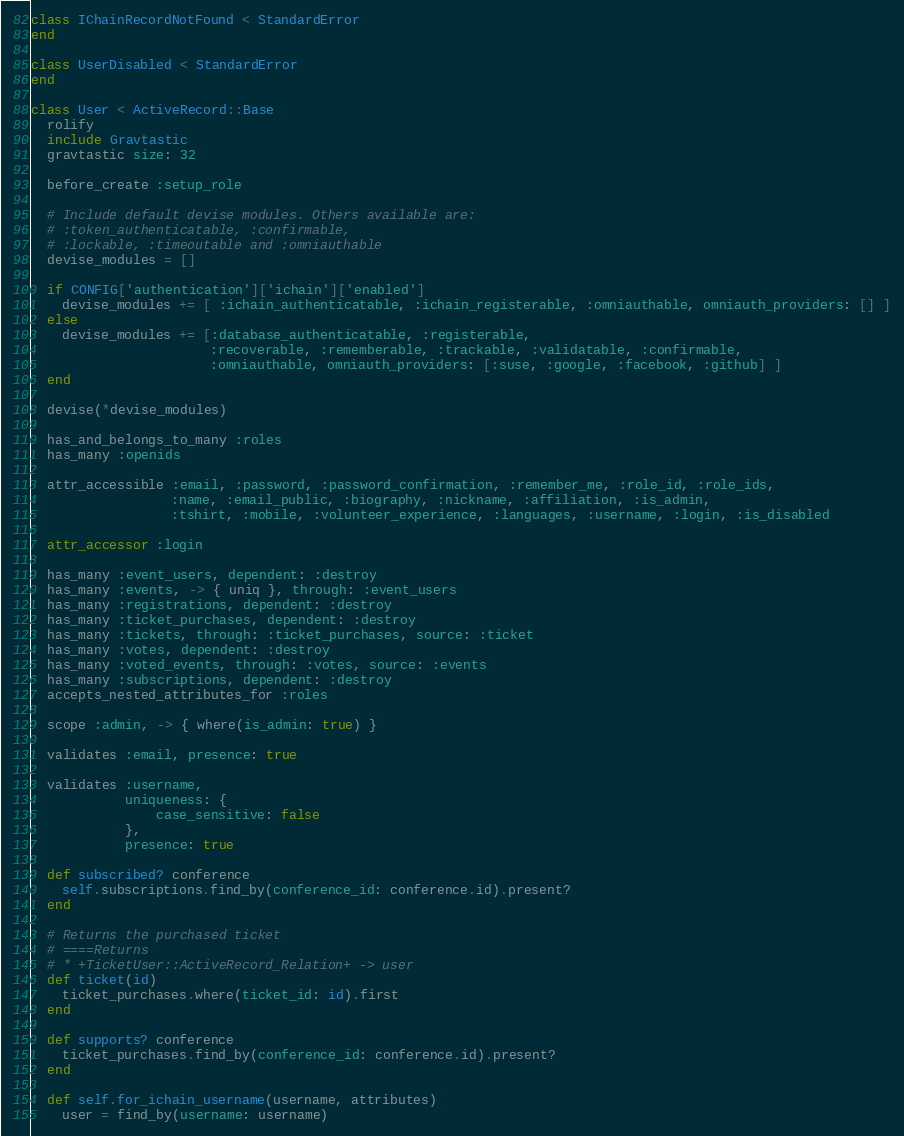Convert code to text. <code><loc_0><loc_0><loc_500><loc_500><_Ruby_>class IChainRecordNotFound < StandardError
end

class UserDisabled < StandardError
end

class User < ActiveRecord::Base
  rolify
  include Gravtastic
  gravtastic size: 32

  before_create :setup_role

  # Include default devise modules. Others available are:
  # :token_authenticatable, :confirmable,
  # :lockable, :timeoutable and :omniauthable
  devise_modules = []

  if CONFIG['authentication']['ichain']['enabled']
    devise_modules += [ :ichain_authenticatable, :ichain_registerable, :omniauthable, omniauth_providers: [] ]
  else
    devise_modules += [:database_authenticatable, :registerable,
                       :recoverable, :rememberable, :trackable, :validatable, :confirmable,
                       :omniauthable, omniauth_providers: [:suse, :google, :facebook, :github] ]
  end

  devise(*devise_modules)

  has_and_belongs_to_many :roles
  has_many :openids

  attr_accessible :email, :password, :password_confirmation, :remember_me, :role_id, :role_ids,
                  :name, :email_public, :biography, :nickname, :affiliation, :is_admin,
                  :tshirt, :mobile, :volunteer_experience, :languages, :username, :login, :is_disabled

  attr_accessor :login

  has_many :event_users, dependent: :destroy
  has_many :events, -> { uniq }, through: :event_users
  has_many :registrations, dependent: :destroy
  has_many :ticket_purchases, dependent: :destroy
  has_many :tickets, through: :ticket_purchases, source: :ticket
  has_many :votes, dependent: :destroy
  has_many :voted_events, through: :votes, source: :events
  has_many :subscriptions, dependent: :destroy
  accepts_nested_attributes_for :roles

  scope :admin, -> { where(is_admin: true) }

  validates :email, presence: true

  validates :username,
            uniqueness: {
                case_sensitive: false
            },
            presence: true

  def subscribed? conference
    self.subscriptions.find_by(conference_id: conference.id).present?
  end

  # Returns the purchased ticket
  # ====Returns
  # * +TicketUser::ActiveRecord_Relation+ -> user
  def ticket(id)
    ticket_purchases.where(ticket_id: id).first
  end

  def supports? conference
    ticket_purchases.find_by(conference_id: conference.id).present?
  end

  def self.for_ichain_username(username, attributes)
    user = find_by(username: username)
</code> 